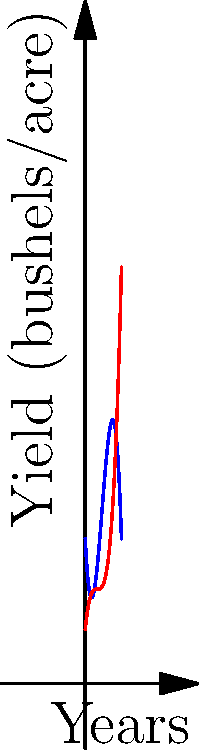Looking at the graph showing corn and wheat yields over a 10-year period, during which year do the yields of corn and wheat appear to be equal? What insights can you share about crop management based on these trends? To find the year when corn and wheat yields are equal, we need to identify where the blue (corn) and red (wheat) curves intersect. Let's approach this step-by-step:

1. Visually inspect the graph to estimate the intersection point.
2. The curves appear to intersect around the 5-year mark.
3. At this point, both crops have a yield of approximately 55 bushels/acre.

Now, let's consider some insights about crop management:

1. Corn yield (blue curve):
   - Starts higher but decreases over time
   - Shows a concave shape, indicating diminishing returns

2. Wheat yield (red curve):
   - Starts lower but increases over time
   - Shows a convex shape, suggesting improving conditions or techniques

3. Crossover point:
   - Around year 5, both crops yield similarly
   - This could be a critical decision point for crop rotation or resource allocation

4. Long-term trends:
   - After year 5, wheat outperforms corn
   - This might suggest a shift in farming focus or the need for improved corn cultivation techniques

5. Factors to consider:
   - Soil health and nutrient depletion
   - Climate changes over the decade
   - Improvements in wheat farming techniques
   - Potential issues with corn pests or diseases

These polynomial curves provide valuable insights into long-term crop performance, helping farmers make informed decisions about crop selection, rotation strategies, and resource allocation.
Answer: Year 5; Crop rotation consideration at crossover point, shift focus to wheat after year 5. 